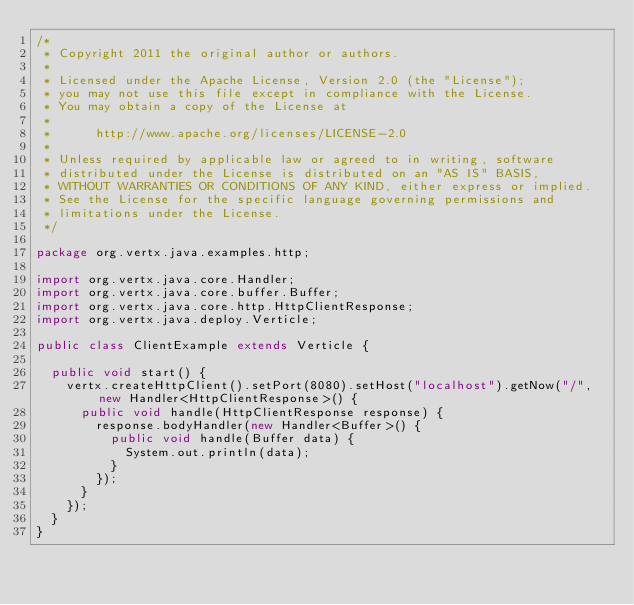Convert code to text. <code><loc_0><loc_0><loc_500><loc_500><_Java_>/*
 * Copyright 2011 the original author or authors.
 *
 * Licensed under the Apache License, Version 2.0 (the "License");
 * you may not use this file except in compliance with the License.
 * You may obtain a copy of the License at
 *
 *      http://www.apache.org/licenses/LICENSE-2.0
 *
 * Unless required by applicable law or agreed to in writing, software
 * distributed under the License is distributed on an "AS IS" BASIS,
 * WITHOUT WARRANTIES OR CONDITIONS OF ANY KIND, either express or implied.
 * See the License for the specific language governing permissions and
 * limitations under the License.
 */

package org.vertx.java.examples.http;

import org.vertx.java.core.Handler;
import org.vertx.java.core.buffer.Buffer;
import org.vertx.java.core.http.HttpClientResponse;
import org.vertx.java.deploy.Verticle;

public class ClientExample extends Verticle {

  public void start() {
    vertx.createHttpClient().setPort(8080).setHost("localhost").getNow("/", new Handler<HttpClientResponse>() {
      public void handle(HttpClientResponse response) {
        response.bodyHandler(new Handler<Buffer>() {
          public void handle(Buffer data) {
            System.out.println(data);
          }
        });
      }
    });
  }
}
</code> 